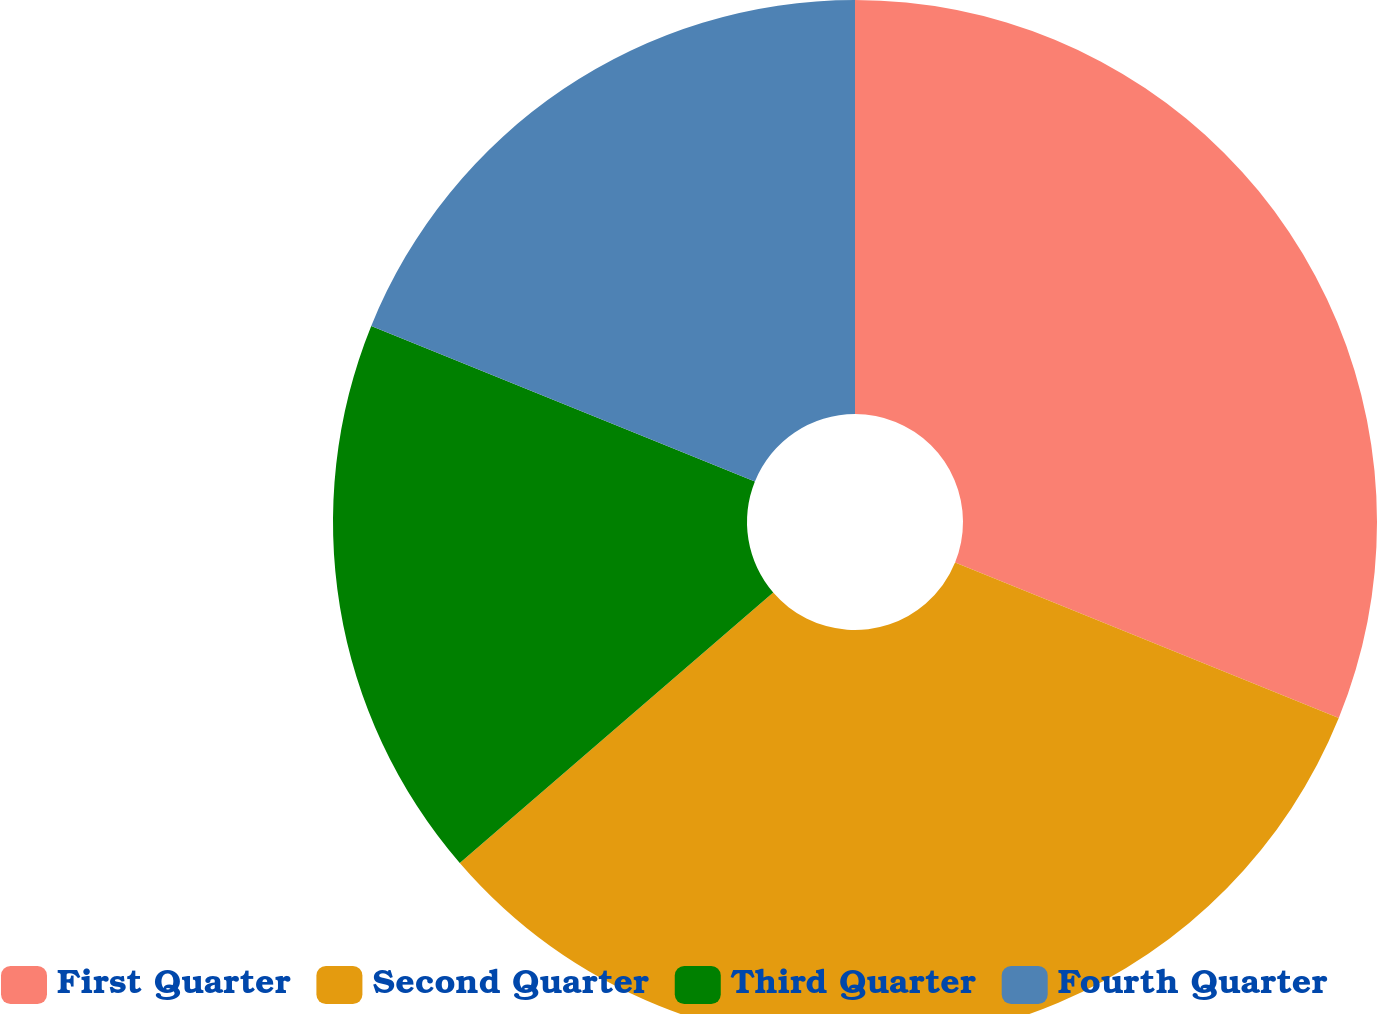Convert chart. <chart><loc_0><loc_0><loc_500><loc_500><pie_chart><fcel>First Quarter<fcel>Second Quarter<fcel>Third Quarter<fcel>Fourth Quarter<nl><fcel>31.13%<fcel>32.54%<fcel>17.46%<fcel>18.87%<nl></chart> 